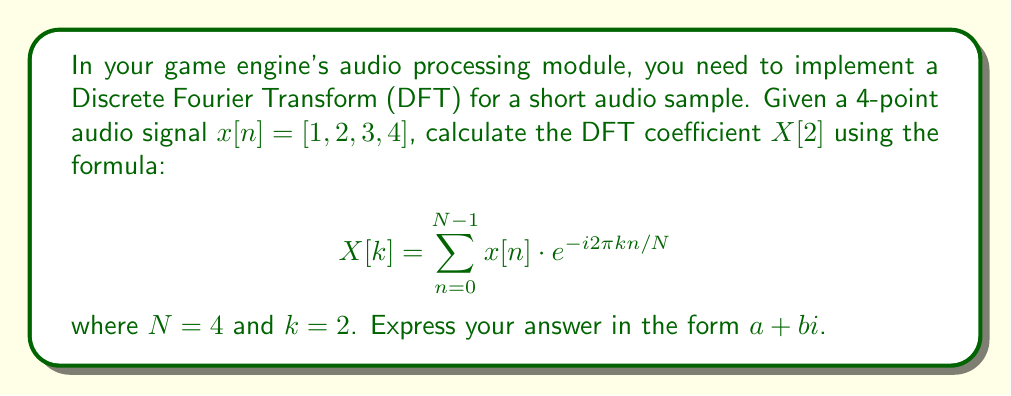What is the answer to this math problem? Let's break this down step-by-step:

1) The DFT formula for $X[2]$ with $N = 4$ is:

   $$X[2] = \sum_{n=0}^{3} x[n] \cdot e^{-i2\pi (2)n/4}$$

2) Expand this sum:

   $$X[2] = x[0] \cdot e^{-i2\pi (2)(0)/4} + x[1] \cdot e^{-i2\pi (2)(1)/4} + x[2] \cdot e^{-i2\pi (2)(2)/4} + x[3] \cdot e^{-i2\pi (2)(3)/4}$$

3) Simplify the exponents:

   $$X[2] = x[0] \cdot e^{0} + x[1] \cdot e^{-i\pi} + x[2] \cdot e^{-i2\pi} + x[3] \cdot e^{-i3\pi}$$

4) Recall that $e^{0} = 1$, $e^{-i\pi} = -1$, $e^{-i2\pi} = 1$, and $e^{-i3\pi} = -1$:

   $$X[2] = x[0] \cdot 1 + x[1] \cdot (-1) + x[2] \cdot 1 + x[3] \cdot (-1)$$

5) Now substitute the values of $x[n] = [1, 2, 3, 4]$:

   $$X[2] = 1 \cdot 1 + 2 \cdot (-1) + 3 \cdot 1 + 4 \cdot (-1)$$

6) Compute:

   $$X[2] = 1 - 2 + 3 - 4 = -2$$

The result is a real number, so the imaginary part is 0.
Answer: $-2 + 0i$ 